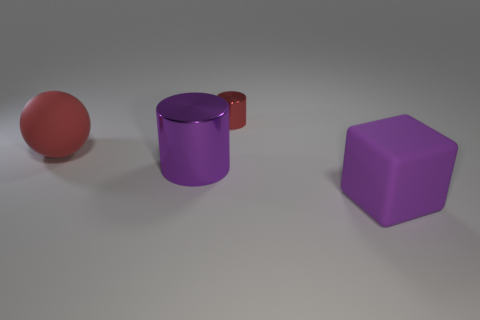Does the large rubber block have the same color as the big metal object?
Give a very brief answer. Yes. Does the cylinder that is left of the tiny metal thing have the same size as the thing that is behind the red rubber ball?
Provide a succinct answer. No. The tiny object behind the rubber thing that is behind the large purple rubber thing is what shape?
Keep it short and to the point. Cylinder. Are there the same number of red rubber spheres that are on the right side of the large purple cube and red matte blocks?
Your answer should be very brief. Yes. What is the material of the big object to the right of the metallic object in front of the red thing that is in front of the small red object?
Keep it short and to the point. Rubber. Are there any red objects that have the same size as the red matte ball?
Give a very brief answer. No. What shape is the big purple rubber thing?
Your response must be concise. Cube. What number of cylinders are tiny blue matte objects or red matte objects?
Ensure brevity in your answer.  0. Are there an equal number of big purple matte blocks behind the purple cylinder and big purple rubber things that are behind the large red matte object?
Provide a succinct answer. Yes. There is a rubber object to the right of the purple object that is left of the big purple cube; what number of tiny metallic cylinders are to the left of it?
Provide a succinct answer. 1. 